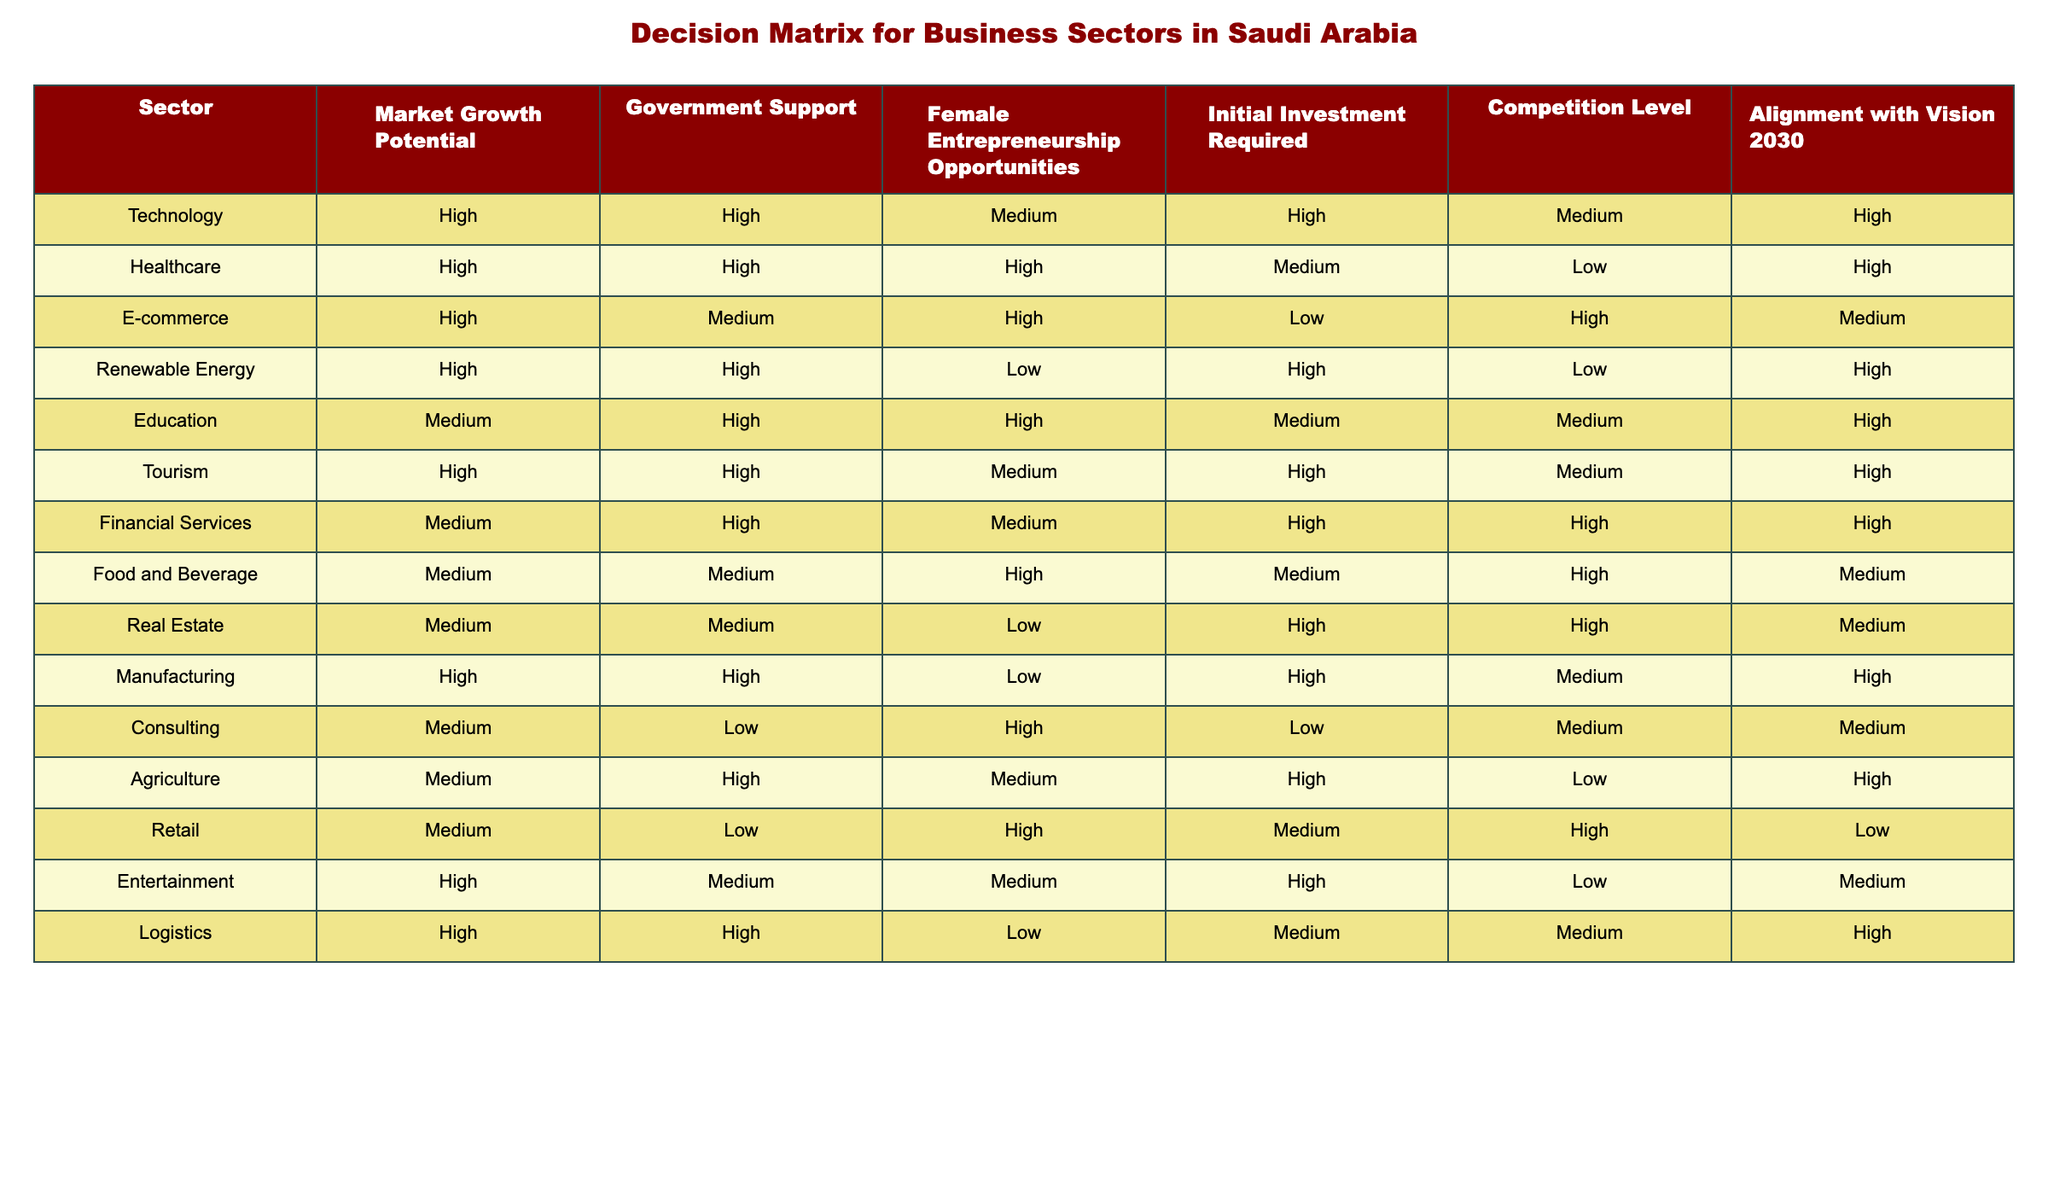What sector has the highest market growth potential? According to the table, the sectors with the highest market growth potential are Technology, Healthcare, E-commerce, Renewable Energy, Tourism, Manufacturing, Logistics, and Entertainment. Therefore, there isn't just one sector; multiple sectors have the same high potential.
Answer: Multiple sectors Which sector has the lowest competition level? From the table, Agriculture and Renewable Energy are indicated as having the lowest competition level, as they both have a "Low" label in that column.
Answer: Agriculture and Renewable Energy What is the average initial investment required for sectors with high market growth potential? The sectors with high market growth potential are Technology, Healthcare, E-commerce, Renewable Energy, Manufacturing, Tourism, Logistics, and Entertainment. The investment required for these sectors is High, Medium, Low, High, High, High, Medium, High. Assigning values (High=3, Medium=2, Low=1), the average calculation is (3 + 2 + 1 + 3 + 3 + 3 + 2 + 3) / 8 = 2.5, which averages to Medium.
Answer: Medium Is there any sector where female entrepreneurship opportunities are rated low? The table shows that Renewable Energy and Real Estate both have a "Low" rating for female entrepreneurship opportunities. Therefore, yes, there are sectors where this is rated low.
Answer: Yes What sectors align with Vision 2030 but do not have high government support? The sectors that align with Vision 2030 are Technology, Healthcare, E-commerce, Renewable Energy, Education, Tourism, Manufacturing, Consulting, Agriculture, Retail, Logistics, and Entertainment. Among these, Consulting and Retail do not have high government support. Therefore, these are the sectors aligning with Vision 2030 but lacking strong government support.
Answer: Consulting and Retail How many sectors offer medium opportunities for female entrepreneurship? Looking at the table, the sectors that offer medium opportunities for female entrepreneurship are Technology, E-commerce, Education, Food and Beverage, Consulting, and Agriculture. Therefore, there are six sectors with medium opportunities for female entrepreneurship.
Answer: Six sectors In which sector is the combination of high market growth potential and low competition found? The table indicates that both Renewable Energy and Agriculture feature high market growth potential alongside low competition. Thus, these sectors express this specific combination.
Answer: Renewable Energy and Agriculture Which sector has both high initial investment and high government support? The sectors with both high initial investment and high government support are Technology, Renewable Energy, Manufacturing, and Logistics. Hence, multiple sectors fulfill both criteria.
Answer: Multiple sectors 